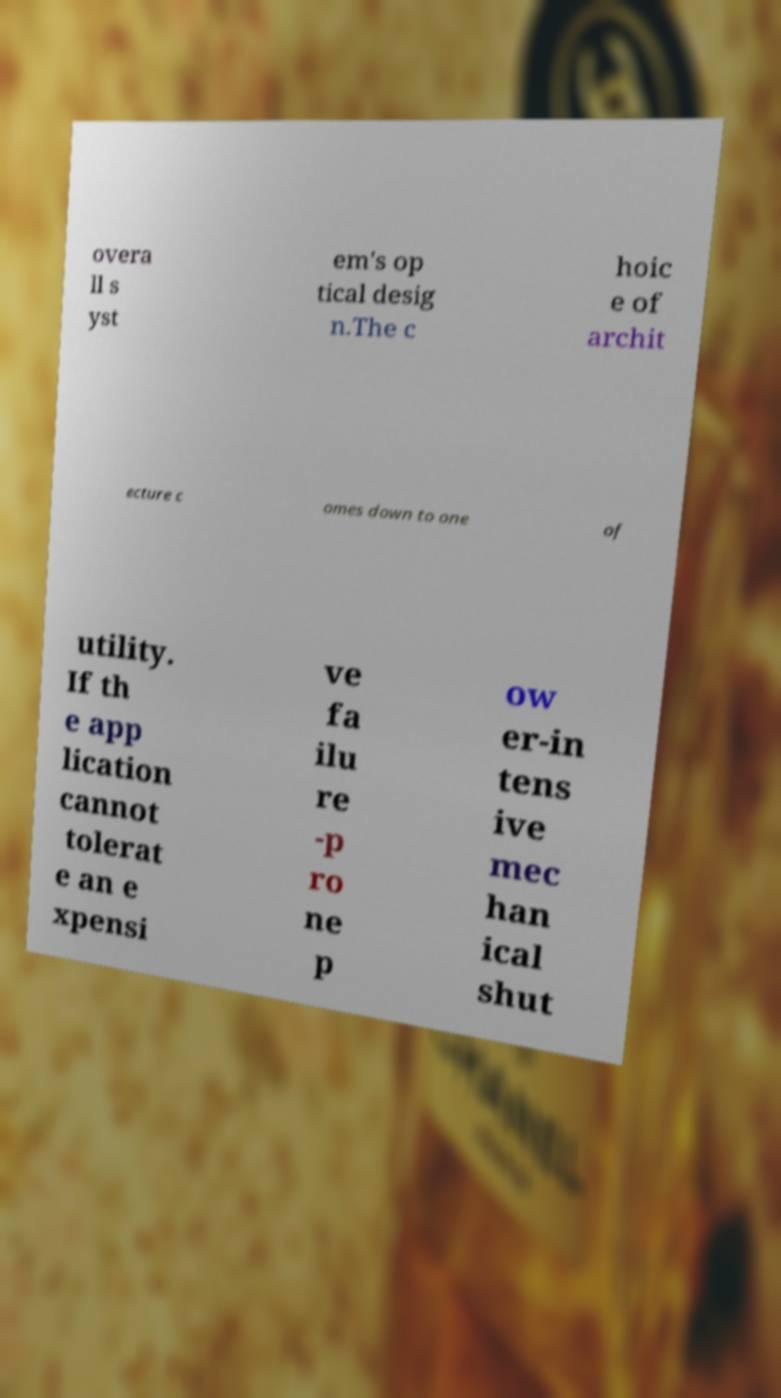Can you accurately transcribe the text from the provided image for me? overa ll s yst em's op tical desig n.The c hoic e of archit ecture c omes down to one of utility. If th e app lication cannot tolerat e an e xpensi ve fa ilu re -p ro ne p ow er-in tens ive mec han ical shut 